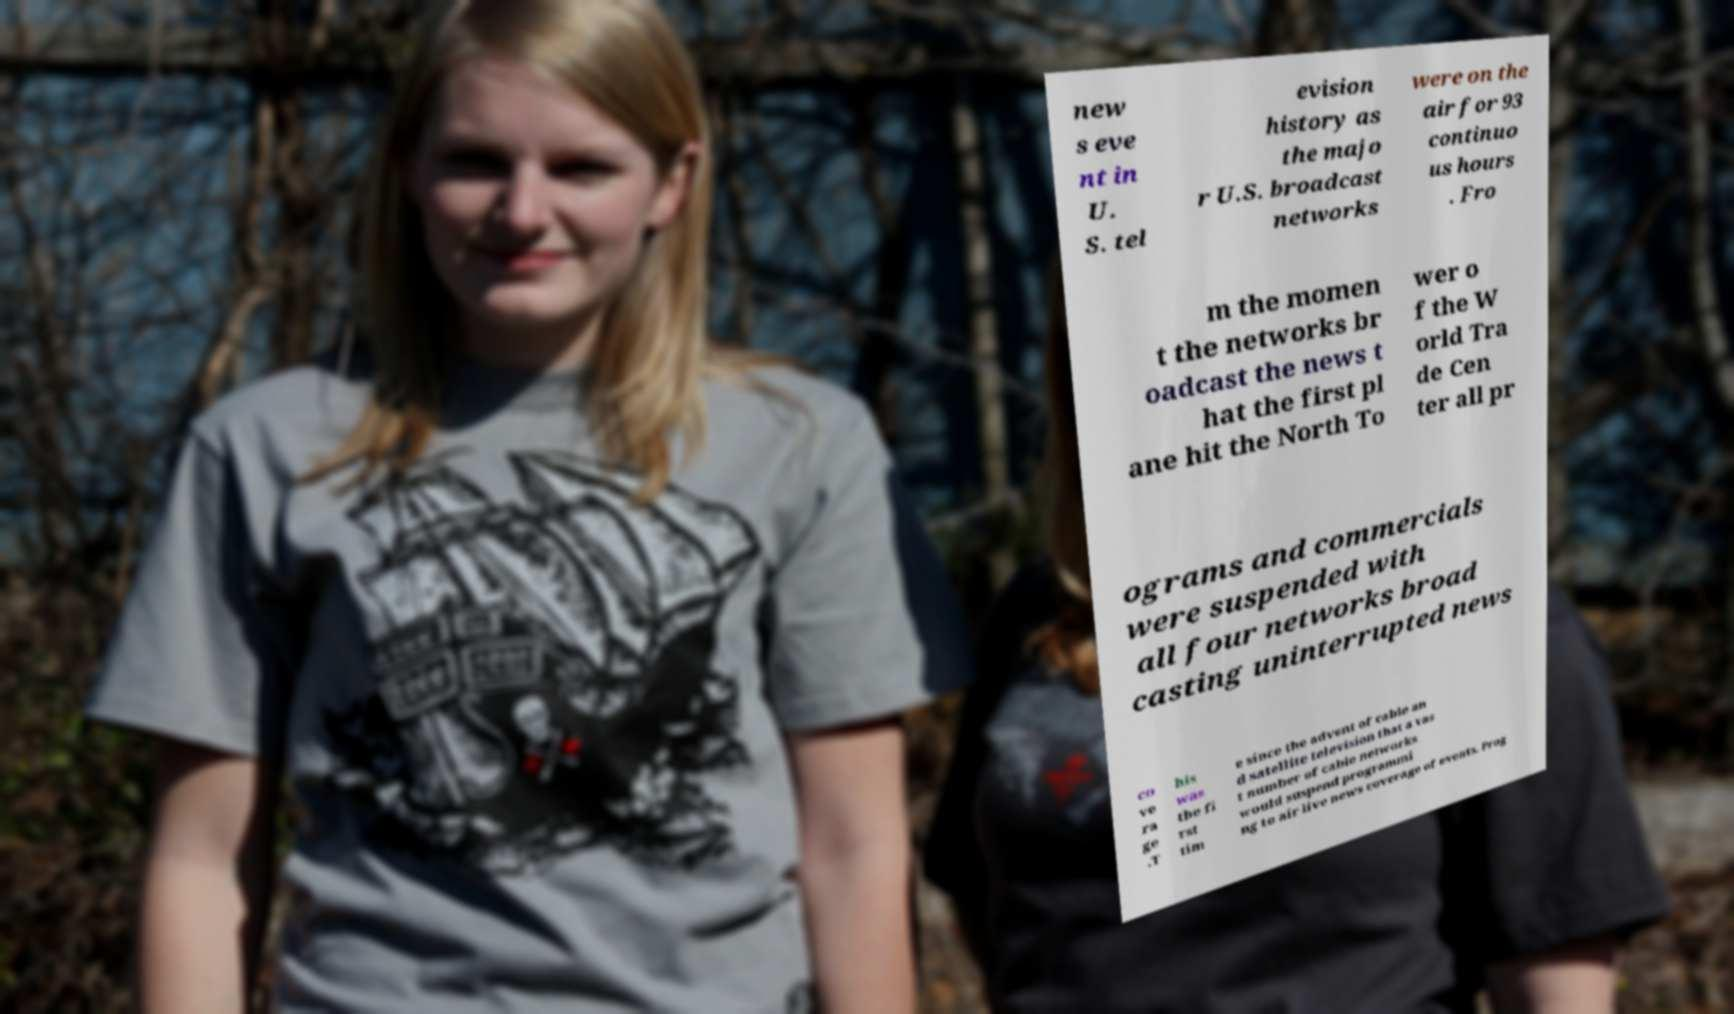I need the written content from this picture converted into text. Can you do that? new s eve nt in U. S. tel evision history as the majo r U.S. broadcast networks were on the air for 93 continuo us hours . Fro m the momen t the networks br oadcast the news t hat the first pl ane hit the North To wer o f the W orld Tra de Cen ter all pr ograms and commercials were suspended with all four networks broad casting uninterrupted news co ve ra ge .T his was the fi rst tim e since the advent of cable an d satellite television that a vas t number of cable networks would suspend programmi ng to air live news coverage of events. Prog 